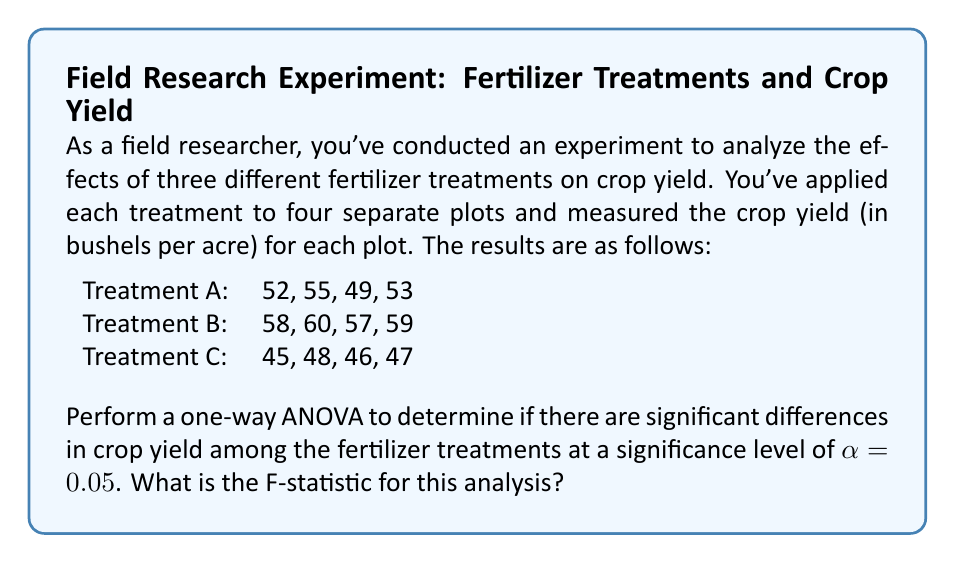Could you help me with this problem? To perform a one-way ANOVA, we'll follow these steps:

1. Calculate the sum of squares between groups (SSB)
2. Calculate the sum of squares within groups (SSW)
3. Calculate the total sum of squares (SST)
4. Calculate the degrees of freedom
5. Calculate the mean squares
6. Calculate the F-statistic

Step 1: Calculate SSB

First, we need to find the grand mean and the means for each treatment:

Grand mean: $\bar{X} = \frac{52+55+49+53+58+60+57+59+45+48+46+47}{12} = 52.417$

Treatment A mean: $\bar{X}_A = \frac{52+55+49+53}{4} = 52.25$
Treatment B mean: $\bar{X}_B = \frac{58+60+57+59}{4} = 58.50$
Treatment C mean: $\bar{X}_C = \frac{45+48+46+47}{4} = 46.50$

Now we can calculate SSB:
$$SSB = \sum_{i=1}^{k} n_i(\bar{X}_i - \bar{X})^2$$
$$SSB = 4(52.25 - 52.417)^2 + 4(58.50 - 52.417)^2 + 4(46.50 - 52.417)^2 = 288.167$$

Step 2: Calculate SSW

$$SSW = \sum_{i=1}^{k} \sum_{j=1}^{n_i} (X_{ij} - \bar{X}_i)^2$$

For Treatment A: $(52-52.25)^2 + (55-52.25)^2 + (49-52.25)^2 + (53-52.25)^2 = 18.75$
For Treatment B: $(58-58.50)^2 + (60-58.50)^2 + (57-58.50)^2 + (59-58.50)^2 = 5.00$
For Treatment C: $(45-46.50)^2 + (48-46.50)^2 + (46-46.50)^2 + (47-46.50)^2 = 5.00$

$$SSW = 18.75 + 5.00 + 5.00 = 28.75$$

Step 3: Calculate SST

$$SST = SSB + SSW = 288.167 + 28.75 = 316.917$$

Step 4: Calculate degrees of freedom

Between groups: $df_B = k - 1 = 3 - 1 = 2$
Within groups: $df_W = N - k = 12 - 3 = 9$
Total: $df_T = N - 1 = 12 - 1 = 11$

Step 5: Calculate mean squares

$$MSB = \frac{SSB}{df_B} = \frac{288.167}{2} = 144.083$$
$$MSW = \frac{SSW}{df_W} = \frac{28.75}{9} = 3.194$$

Step 6: Calculate F-statistic

$$F = \frac{MSB}{MSW} = \frac{144.083}{3.194} = 45.110$$

Therefore, the F-statistic for this analysis is 45.110.
Answer: $F = 45.110$ 